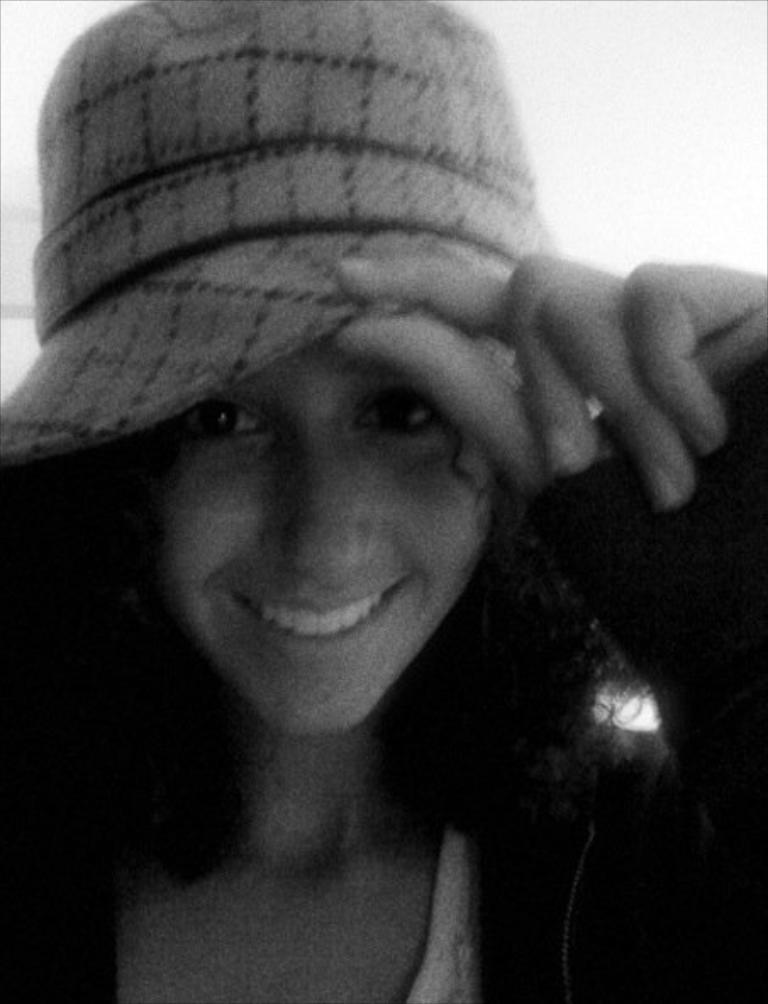In one or two sentences, can you explain what this image depicts? This is a black and white image. In the center of the image there is a girl wearing a cap. 